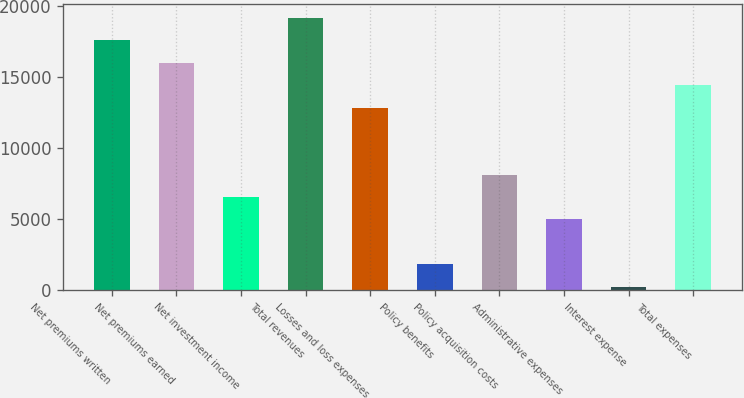Convert chart. <chart><loc_0><loc_0><loc_500><loc_500><bar_chart><fcel>Net premiums written<fcel>Net premiums earned<fcel>Net investment income<fcel>Total revenues<fcel>Losses and loss expenses<fcel>Policy benefits<fcel>Policy acquisition costs<fcel>Administrative expenses<fcel>Interest expense<fcel>Total expenses<nl><fcel>17584.2<fcel>16006<fcel>6536.8<fcel>19162.4<fcel>12849.6<fcel>1802.2<fcel>8115<fcel>4958.6<fcel>224<fcel>14427.8<nl></chart> 